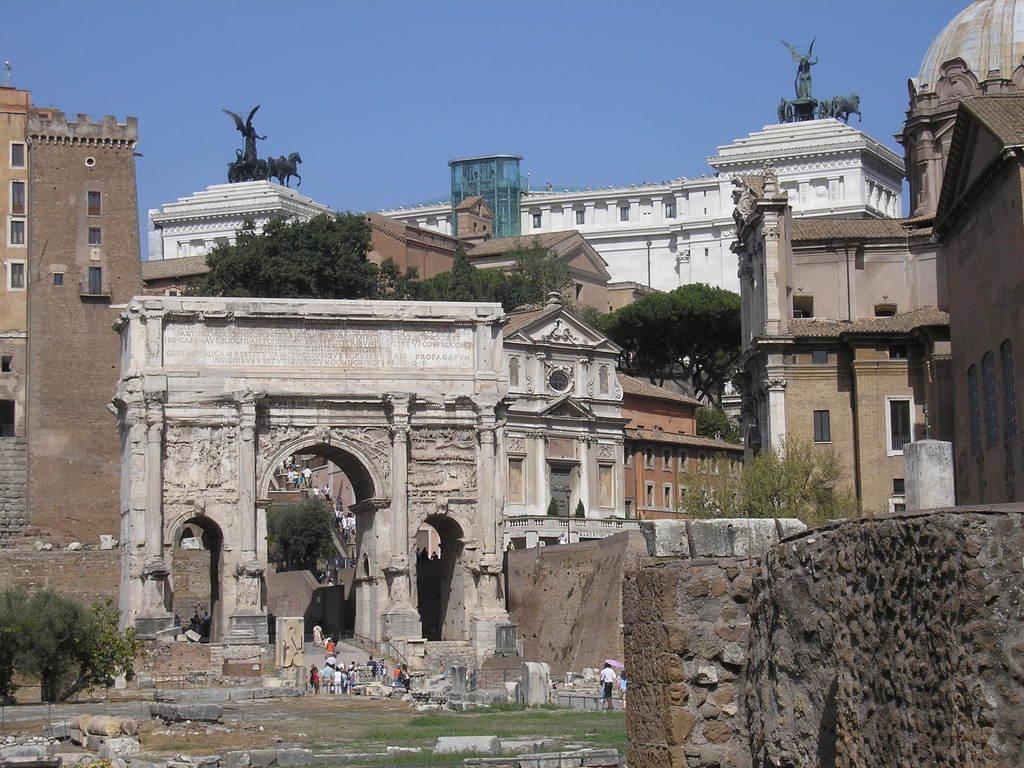Please provide a concise description of this image. In this image there are few persons on the land. Few persons are climbing the stairs. Beside the stairs there are few trees. There is an entrance. Behind there are few buildings and trees. A statue is on the building. Right side there is a wall. Bottom of the image there are few rocks on the land having few trees. Top of the image there is sky. Right side there is a statue on the building. 